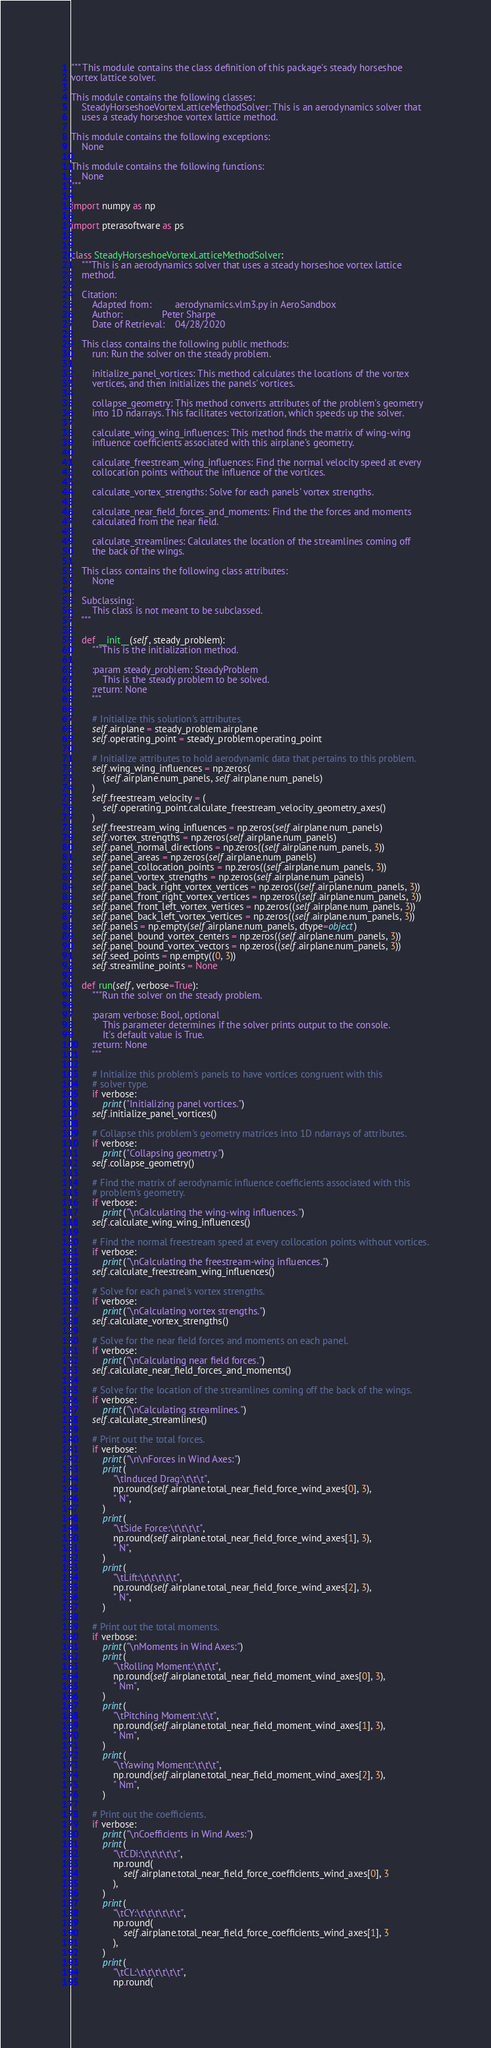<code> <loc_0><loc_0><loc_500><loc_500><_Python_>""" This module contains the class definition of this package's steady horseshoe
vortex lattice solver.

This module contains the following classes:
    SteadyHorseshoeVortexLatticeMethodSolver: This is an aerodynamics solver that
    uses a steady horseshoe vortex lattice method.

This module contains the following exceptions:
    None

This module contains the following functions:
    None
"""

import numpy as np

import pterasoftware as ps


class SteadyHorseshoeVortexLatticeMethodSolver:
    """This is an aerodynamics solver that uses a steady horseshoe vortex lattice
    method.

    Citation:
        Adapted from:         aerodynamics.vlm3.py in AeroSandbox
        Author:               Peter Sharpe
        Date of Retrieval:    04/28/2020

    This class contains the following public methods:
        run: Run the solver on the steady problem.

        initialize_panel_vortices: This method calculates the locations of the vortex
        vertices, and then initializes the panels' vortices.

        collapse_geometry: This method converts attributes of the problem's geometry
        into 1D ndarrays. This facilitates vectorization, which speeds up the solver.

        calculate_wing_wing_influences: This method finds the matrix of wing-wing
        influence coefficients associated with this airplane's geometry.

        calculate_freestream_wing_influences: Find the normal velocity speed at every
        collocation points without the influence of the vortices.

        calculate_vortex_strengths: Solve for each panels' vortex strengths.

        calculate_near_field_forces_and_moments: Find the the forces and moments
        calculated from the near field.

        calculate_streamlines: Calculates the location of the streamlines coming off
        the back of the wings.

    This class contains the following class attributes:
        None

    Subclassing:
        This class is not meant to be subclassed.
    """

    def __init__(self, steady_problem):
        """This is the initialization method.

        :param steady_problem: SteadyProblem
            This is the steady problem to be solved.
        :return: None
        """

        # Initialize this solution's attributes.
        self.airplane = steady_problem.airplane
        self.operating_point = steady_problem.operating_point

        # Initialize attributes to hold aerodynamic data that pertains to this problem.
        self.wing_wing_influences = np.zeros(
            (self.airplane.num_panels, self.airplane.num_panels)
        )
        self.freestream_velocity = (
            self.operating_point.calculate_freestream_velocity_geometry_axes()
        )
        self.freestream_wing_influences = np.zeros(self.airplane.num_panels)
        self.vortex_strengths = np.zeros(self.airplane.num_panels)
        self.panel_normal_directions = np.zeros((self.airplane.num_panels, 3))
        self.panel_areas = np.zeros(self.airplane.num_panels)
        self.panel_collocation_points = np.zeros((self.airplane.num_panels, 3))
        self.panel_vortex_strengths = np.zeros(self.airplane.num_panels)
        self.panel_back_right_vortex_vertices = np.zeros((self.airplane.num_panels, 3))
        self.panel_front_right_vortex_vertices = np.zeros((self.airplane.num_panels, 3))
        self.panel_front_left_vortex_vertices = np.zeros((self.airplane.num_panels, 3))
        self.panel_back_left_vortex_vertices = np.zeros((self.airplane.num_panels, 3))
        self.panels = np.empty(self.airplane.num_panels, dtype=object)
        self.panel_bound_vortex_centers = np.zeros((self.airplane.num_panels, 3))
        self.panel_bound_vortex_vectors = np.zeros((self.airplane.num_panels, 3))
        self.seed_points = np.empty((0, 3))
        self.streamline_points = None

    def run(self, verbose=True):
        """Run the solver on the steady problem.

        :param verbose: Bool, optional
            This parameter determines if the solver prints output to the console.
            It's default value is True.
        :return: None
        """

        # Initialize this problem's panels to have vortices congruent with this
        # solver type.
        if verbose:
            print("Initializing panel vortices.")
        self.initialize_panel_vortices()

        # Collapse this problem's geometry matrices into 1D ndarrays of attributes.
        if verbose:
            print("Collapsing geometry.")
        self.collapse_geometry()

        # Find the matrix of aerodynamic influence coefficients associated with this
        # problem's geometry.
        if verbose:
            print("\nCalculating the wing-wing influences.")
        self.calculate_wing_wing_influences()

        # Find the normal freestream speed at every collocation points without vortices.
        if verbose:
            print("\nCalculating the freestream-wing influences.")
        self.calculate_freestream_wing_influences()

        # Solve for each panel's vortex strengths.
        if verbose:
            print("\nCalculating vortex strengths.")
        self.calculate_vortex_strengths()

        # Solve for the near field forces and moments on each panel.
        if verbose:
            print("\nCalculating near field forces.")
        self.calculate_near_field_forces_and_moments()

        # Solve for the location of the streamlines coming off the back of the wings.
        if verbose:
            print("\nCalculating streamlines.")
        self.calculate_streamlines()

        # Print out the total forces.
        if verbose:
            print("\n\nForces in Wind Axes:")
            print(
                "\tInduced Drag:\t\t\t",
                np.round(self.airplane.total_near_field_force_wind_axes[0], 3),
                " N",
            )
            print(
                "\tSide Force:\t\t\t\t",
                np.round(self.airplane.total_near_field_force_wind_axes[1], 3),
                " N",
            )
            print(
                "\tLift:\t\t\t\t\t",
                np.round(self.airplane.total_near_field_force_wind_axes[2], 3),
                " N",
            )

        # Print out the total moments.
        if verbose:
            print("\nMoments in Wind Axes:")
            print(
                "\tRolling Moment:\t\t\t",
                np.round(self.airplane.total_near_field_moment_wind_axes[0], 3),
                " Nm",
            )
            print(
                "\tPitching Moment:\t\t",
                np.round(self.airplane.total_near_field_moment_wind_axes[1], 3),
                " Nm",
            )
            print(
                "\tYawing Moment:\t\t\t",
                np.round(self.airplane.total_near_field_moment_wind_axes[2], 3),
                " Nm",
            )

        # Print out the coefficients.
        if verbose:
            print("\nCoefficients in Wind Axes:")
            print(
                "\tCDi:\t\t\t\t\t",
                np.round(
                    self.airplane.total_near_field_force_coefficients_wind_axes[0], 3
                ),
            )
            print(
                "\tCY:\t\t\t\t\t\t",
                np.round(
                    self.airplane.total_near_field_force_coefficients_wind_axes[1], 3
                ),
            )
            print(
                "\tCL:\t\t\t\t\t\t",
                np.round(</code> 